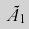Convert formula to latex. <formula><loc_0><loc_0><loc_500><loc_500>\tilde { A } _ { 1 }</formula> 